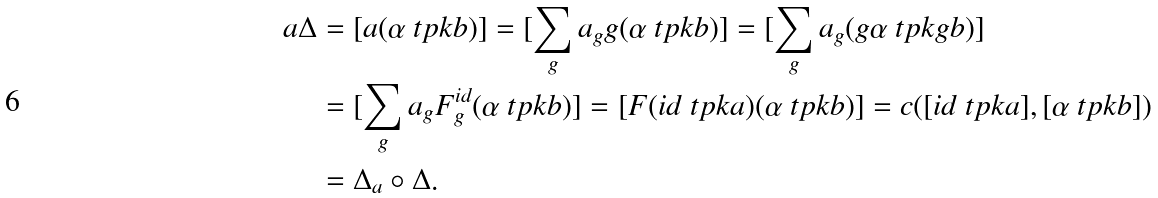Convert formula to latex. <formula><loc_0><loc_0><loc_500><loc_500>a \Delta & = [ a ( \alpha \ t p k b ) ] = [ \sum _ { g } a _ { g } g ( \alpha \ t p k b ) ] = [ \sum _ { g } a _ { g } ( g \alpha \ t p k g b ) ] \\ & = [ \sum _ { g } a _ { g } F _ { g } ^ { i d } ( \alpha \ t p k b ) ] = [ F ( i d \ t p k a ) ( \alpha \ t p k b ) ] = c ( [ i d \ t p k a ] , [ \alpha \ t p k b ] ) \\ & = \Delta _ { a } \circ \Delta .</formula> 